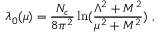Convert formula to latex. <formula><loc_0><loc_0><loc_500><loc_500>\lambda _ { 0 } ( \mu ) = { \frac { N _ { c } } { 8 \pi ^ { 2 } } } \ln ( { \frac { \Lambda ^ { 2 } + M ^ { 2 } } { \mu ^ { 2 } + M ^ { 2 } } } ) \ ,</formula> 